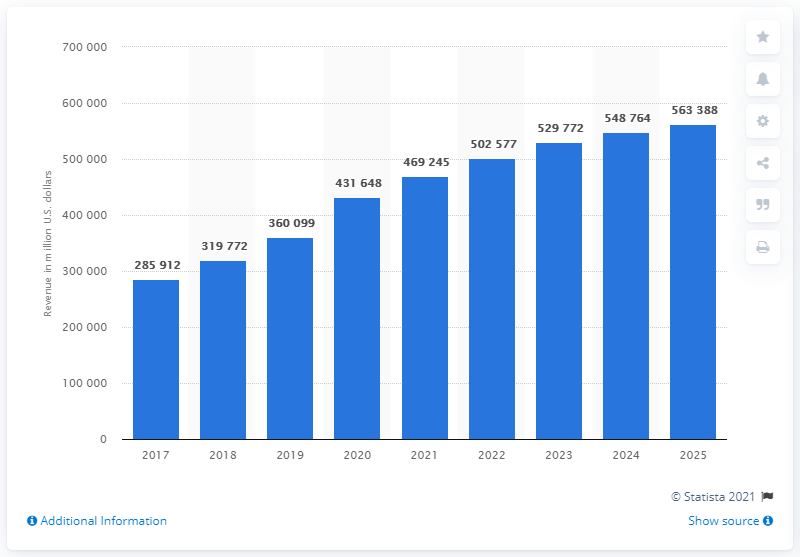Does the graph provide any insights into the prediction accuracy for the future e-commerce revenue? The graph includes projected revenues up to 2025, which show continued growth. However, since these are projections, they're based on current trends and modeling and are subject to change based on various economic factors, consumer behaviors, and market conditions.  Can we determine any external factors that may affect these predictions? External factors that could affect these predictions include changes in economic stability, shifts in consumer shopping habits, technological innovations in e-commerce, and regulatory changes affecting online trade. Also, global events like pandemics can have a profound, if unpredictable, impact on e-commerce trends. 